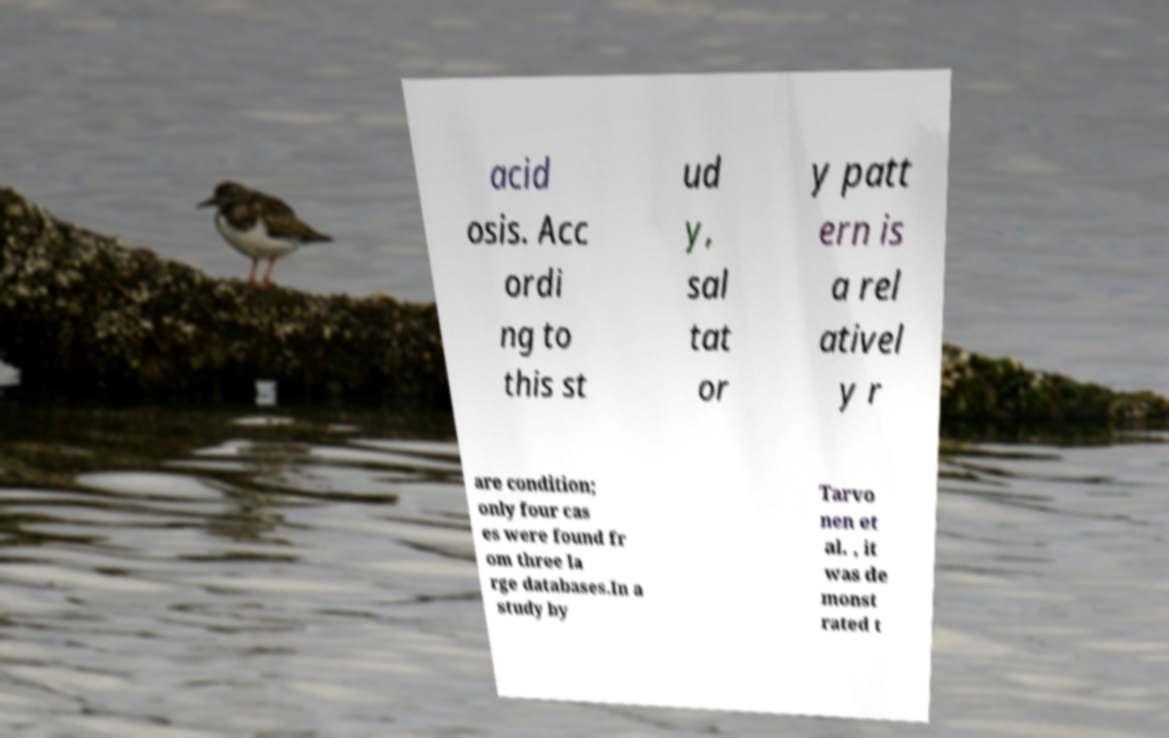Please read and relay the text visible in this image. What does it say? acid osis. Acc ordi ng to this st ud y, sal tat or y patt ern is a rel ativel y r are condition; only four cas es were found fr om three la rge databases.In a study by Tarvo nen et al. , it was de monst rated t 